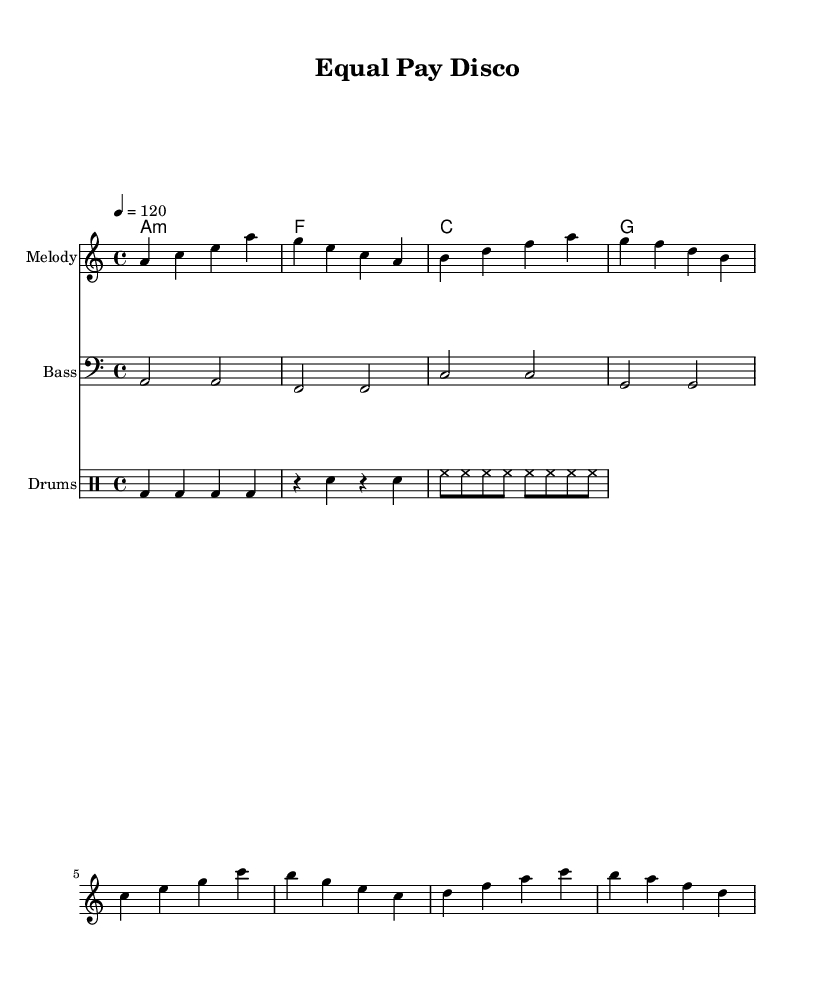What is the key signature of this music? The key signature is indicated by the absence of sharps or flats at the beginning of the staff. Therefore, it is the key of A minor, which is the relative minor of C major.
Answer: A minor What is the time signature of this music? The time signature is located at the beginning of the sheet music, represented by the numbers above the staff. In this case, it shows 4 over 4, which means there are four beats in each measure and the quarter note gets one beat.
Answer: 4/4 What is the tempo marking of this music? The tempo marking is noted as "4 = 120" which indicates that there are 120 beats per minute, and each quarter note receives one beat in the pulse of the music.
Answer: 120 How many measures are there in the melody? The melody contains a total of eight measures, counted from the beginning until the end, where phrases and bars are defined by vertical lines.
Answer: 8 What type of bass clef is used in this piece? The bass line is written in bass clef, which is the clef that indicates lower pitches, used primarily for instruments like the bass guitar and piano for lower notes.
Answer: Bass clef What are the primary chords used in the harmony? The harmony is indicated in the chord mode section and clearly shows four chords: A minor, F major, C major, and G major, which are typical of disco music.
Answer: A minor, F major, C major, G major What instrumental role does the drum part serve in the arrangement? The drum part is structured to provide rhythmic support, including different components like bass drum, snare drum, and hi-hat, crucial for maintaining the upbeat tempo typical in disco music.
Answer: Rhythmic support 